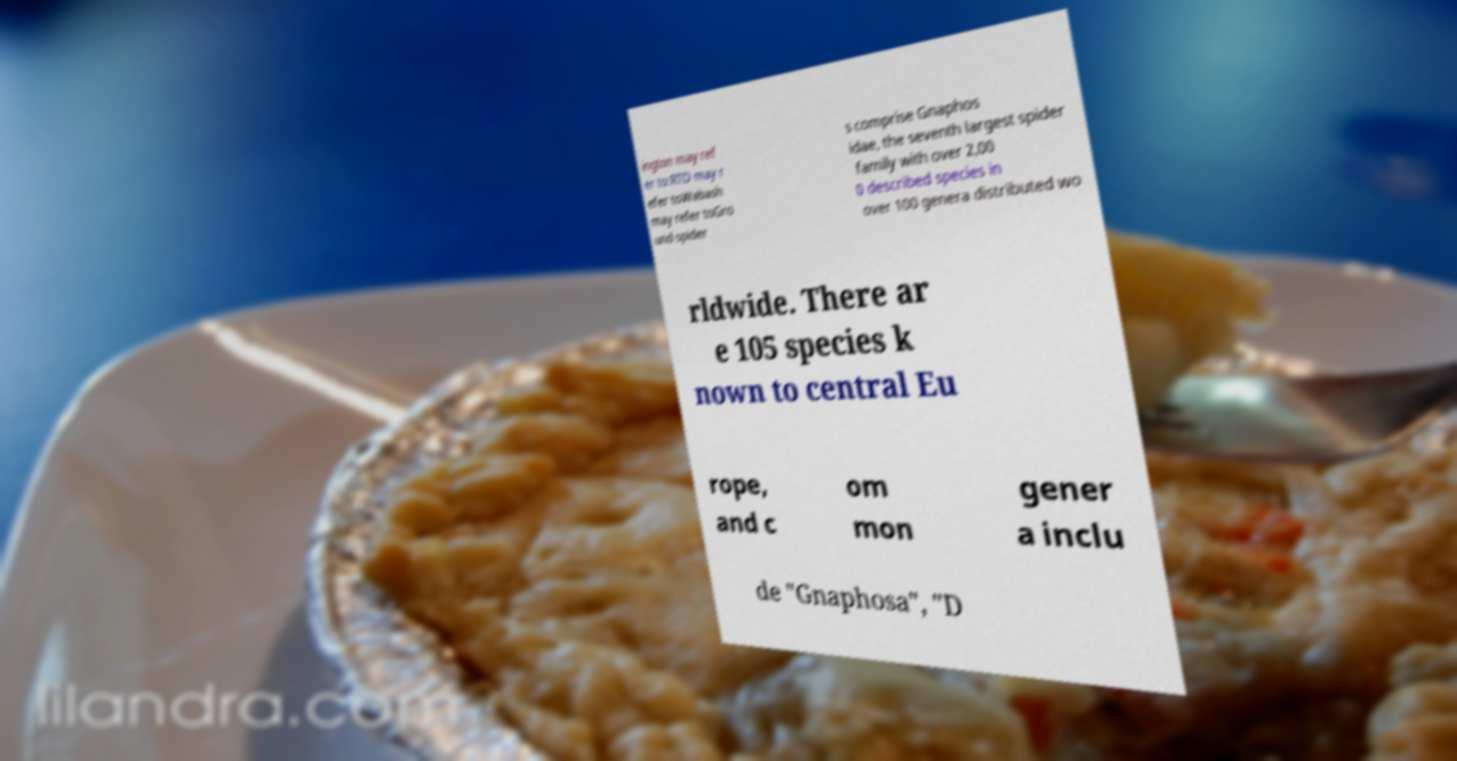There's text embedded in this image that I need extracted. Can you transcribe it verbatim? ington may ref er to:RTD may r efer toWabash may refer toGro und spider s comprise Gnaphos idae, the seventh largest spider family with over 2,00 0 described species in over 100 genera distributed wo rldwide. There ar e 105 species k nown to central Eu rope, and c om mon gener a inclu de "Gnaphosa", "D 